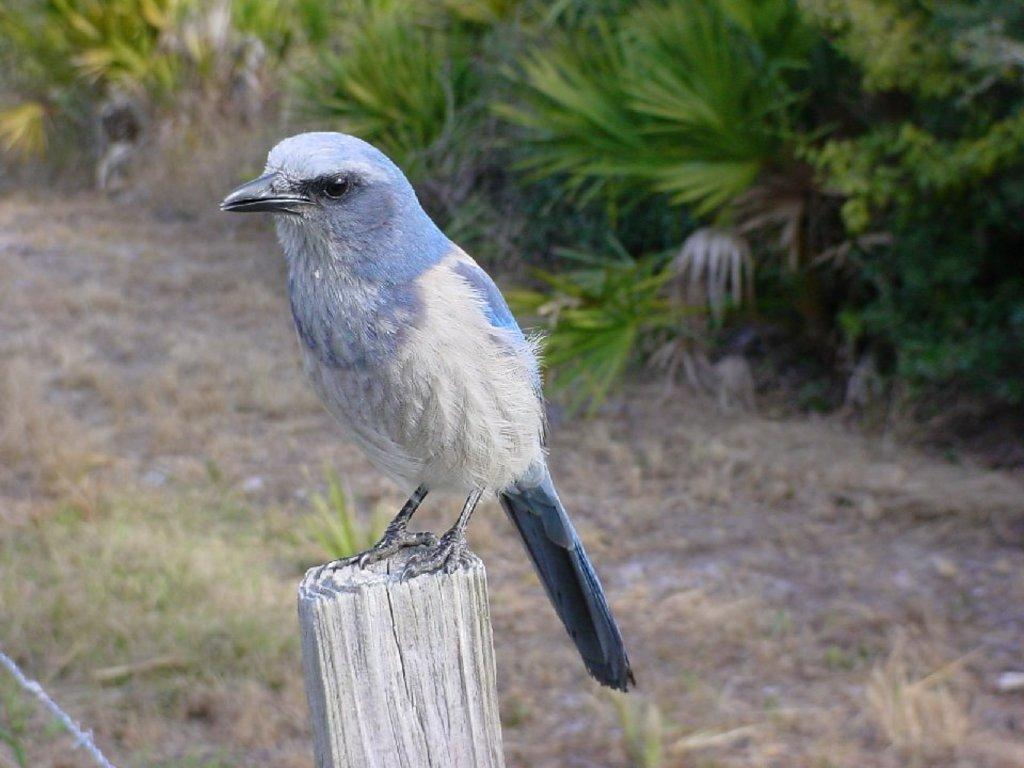What type of animal is in the image? There is a bird in the image. What is the bird standing on? The bird is standing on a wooden pole. Can you describe the bird's coloring? The bird has blue and white coloring. What type of natural environment is visible in the image? There are trees visible in the image. What type of cent can be seen in the image? There is no cent present in the image; it features a bird standing on a wooden pole. What kind of surprise is the bird holding in the image? There is no surprise visible in the image; the bird is simply standing on a wooden pole. 